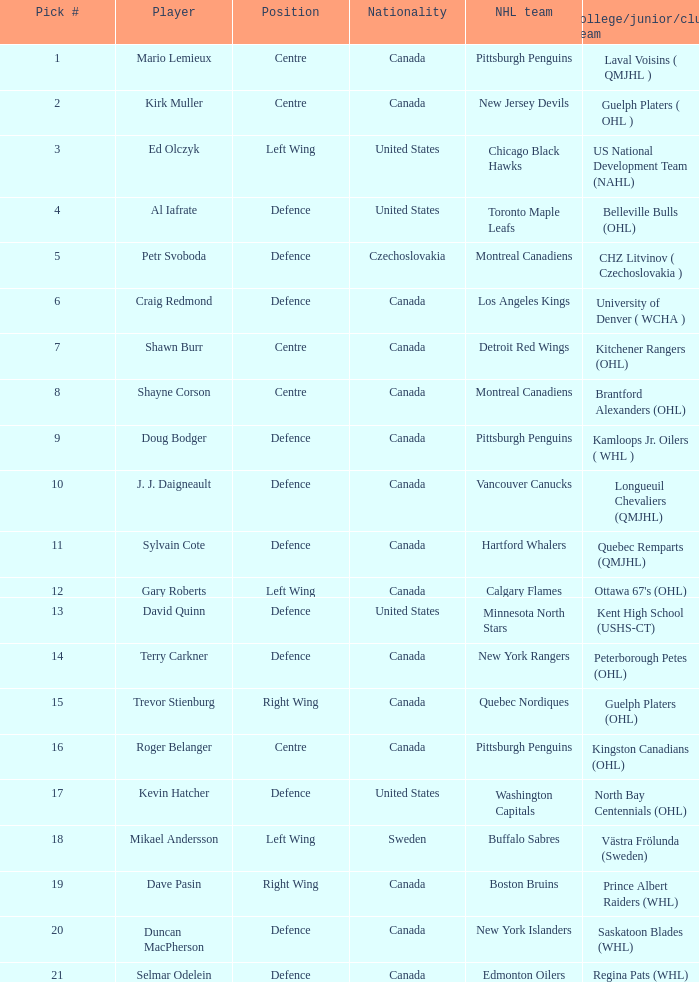What college team did draft pick 18 come from? Västra Frölunda (Sweden). 